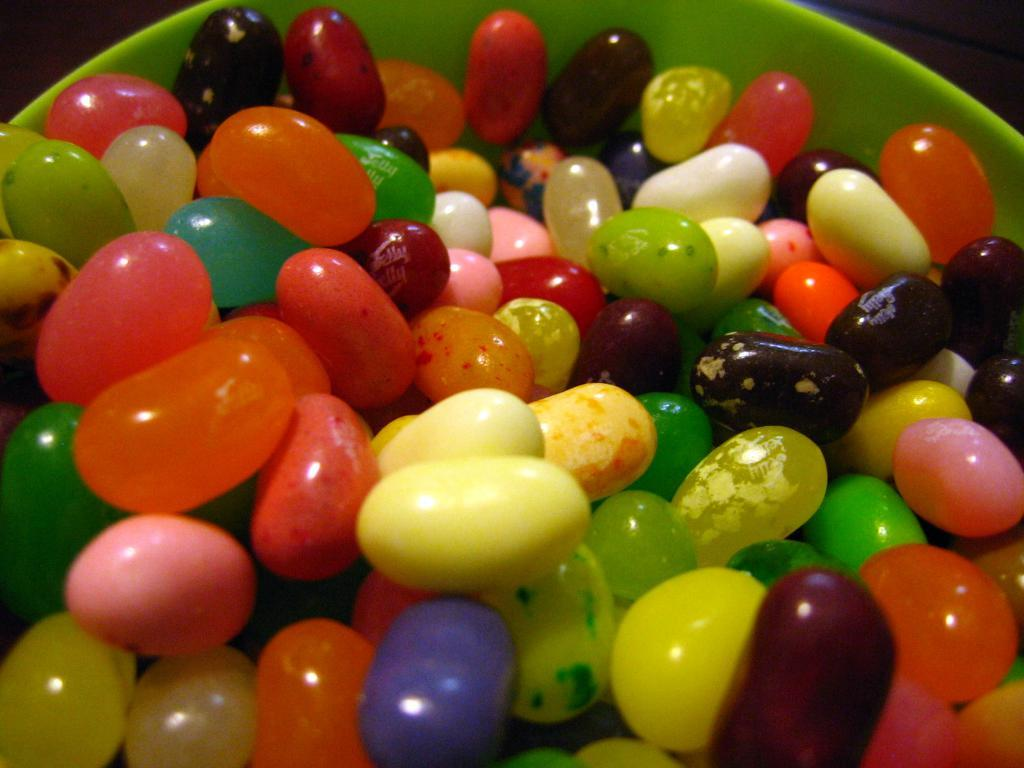What is the main object in the image? There is a bowl in the image. What color is the bowl? The bowl is green in color. What is inside the bowl? There are colorful candies in the bowl. How many trains can be seen passing by the house in the image? There is no house or trains present in the image; it only features a green bowl with colorful candies. 